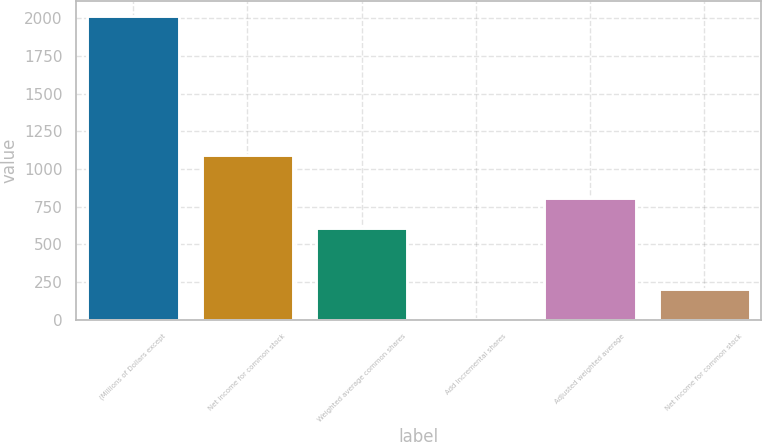Convert chart. <chart><loc_0><loc_0><loc_500><loc_500><bar_chart><fcel>(Millions of Dollars except<fcel>Net income for common stock<fcel>Weighted average common shares<fcel>Add Incremental shares<fcel>Adjusted weighted average<fcel>Net Income for common stock<nl><fcel>2014<fcel>1092<fcel>604.97<fcel>1.1<fcel>806.26<fcel>202.39<nl></chart> 